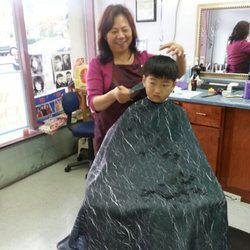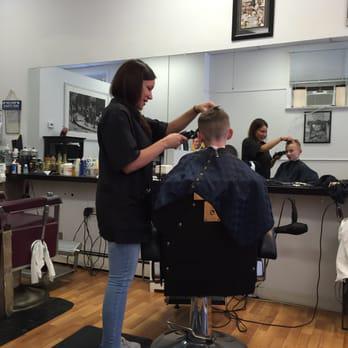The first image is the image on the left, the second image is the image on the right. For the images displayed, is the sentence "A woman is cutting a male's hair in at least one of the images." factually correct? Answer yes or no. Yes. The first image is the image on the left, the second image is the image on the right. Considering the images on both sides, is "One image is the outside of a barber shop and the other image is the inside of a barber shop." valid? Answer yes or no. No. 